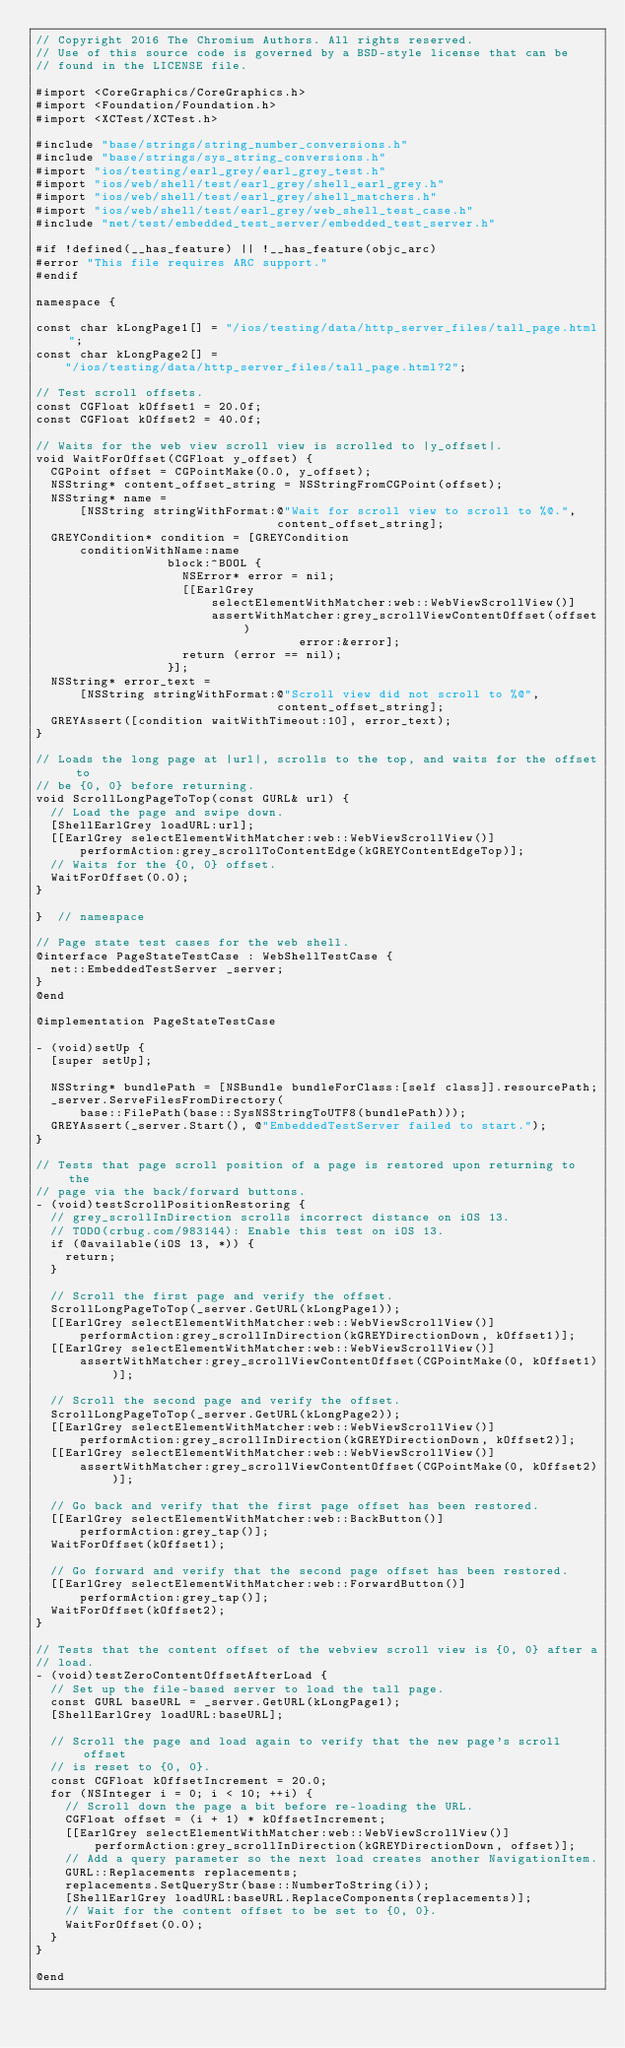<code> <loc_0><loc_0><loc_500><loc_500><_ObjectiveC_>// Copyright 2016 The Chromium Authors. All rights reserved.
// Use of this source code is governed by a BSD-style license that can be
// found in the LICENSE file.

#import <CoreGraphics/CoreGraphics.h>
#import <Foundation/Foundation.h>
#import <XCTest/XCTest.h>

#include "base/strings/string_number_conversions.h"
#include "base/strings/sys_string_conversions.h"
#import "ios/testing/earl_grey/earl_grey_test.h"
#import "ios/web/shell/test/earl_grey/shell_earl_grey.h"
#import "ios/web/shell/test/earl_grey/shell_matchers.h"
#import "ios/web/shell/test/earl_grey/web_shell_test_case.h"
#include "net/test/embedded_test_server/embedded_test_server.h"

#if !defined(__has_feature) || !__has_feature(objc_arc)
#error "This file requires ARC support."
#endif

namespace {

const char kLongPage1[] = "/ios/testing/data/http_server_files/tall_page.html";
const char kLongPage2[] =
    "/ios/testing/data/http_server_files/tall_page.html?2";

// Test scroll offsets.
const CGFloat kOffset1 = 20.0f;
const CGFloat kOffset2 = 40.0f;

// Waits for the web view scroll view is scrolled to |y_offset|.
void WaitForOffset(CGFloat y_offset) {
  CGPoint offset = CGPointMake(0.0, y_offset);
  NSString* content_offset_string = NSStringFromCGPoint(offset);
  NSString* name =
      [NSString stringWithFormat:@"Wait for scroll view to scroll to %@.",
                                 content_offset_string];
  GREYCondition* condition = [GREYCondition
      conditionWithName:name
                  block:^BOOL {
                    NSError* error = nil;
                    [[EarlGrey
                        selectElementWithMatcher:web::WebViewScrollView()]
                        assertWithMatcher:grey_scrollViewContentOffset(offset)
                                    error:&error];
                    return (error == nil);
                  }];
  NSString* error_text =
      [NSString stringWithFormat:@"Scroll view did not scroll to %@",
                                 content_offset_string];
  GREYAssert([condition waitWithTimeout:10], error_text);
}

// Loads the long page at |url|, scrolls to the top, and waits for the offset to
// be {0, 0} before returning.
void ScrollLongPageToTop(const GURL& url) {
  // Load the page and swipe down.
  [ShellEarlGrey loadURL:url];
  [[EarlGrey selectElementWithMatcher:web::WebViewScrollView()]
      performAction:grey_scrollToContentEdge(kGREYContentEdgeTop)];
  // Waits for the {0, 0} offset.
  WaitForOffset(0.0);
}

}  // namespace

// Page state test cases for the web shell.
@interface PageStateTestCase : WebShellTestCase {
  net::EmbeddedTestServer _server;
}
@end

@implementation PageStateTestCase

- (void)setUp {
  [super setUp];

  NSString* bundlePath = [NSBundle bundleForClass:[self class]].resourcePath;
  _server.ServeFilesFromDirectory(
      base::FilePath(base::SysNSStringToUTF8(bundlePath)));
  GREYAssert(_server.Start(), @"EmbeddedTestServer failed to start.");
}

// Tests that page scroll position of a page is restored upon returning to the
// page via the back/forward buttons.
- (void)testScrollPositionRestoring {
  // grey_scrollInDirection scrolls incorrect distance on iOS 13.
  // TODO(crbug.com/983144): Enable this test on iOS 13.
  if (@available(iOS 13, *)) {
    return;
  }

  // Scroll the first page and verify the offset.
  ScrollLongPageToTop(_server.GetURL(kLongPage1));
  [[EarlGrey selectElementWithMatcher:web::WebViewScrollView()]
      performAction:grey_scrollInDirection(kGREYDirectionDown, kOffset1)];
  [[EarlGrey selectElementWithMatcher:web::WebViewScrollView()]
      assertWithMatcher:grey_scrollViewContentOffset(CGPointMake(0, kOffset1))];

  // Scroll the second page and verify the offset.
  ScrollLongPageToTop(_server.GetURL(kLongPage2));
  [[EarlGrey selectElementWithMatcher:web::WebViewScrollView()]
      performAction:grey_scrollInDirection(kGREYDirectionDown, kOffset2)];
  [[EarlGrey selectElementWithMatcher:web::WebViewScrollView()]
      assertWithMatcher:grey_scrollViewContentOffset(CGPointMake(0, kOffset2))];

  // Go back and verify that the first page offset has been restored.
  [[EarlGrey selectElementWithMatcher:web::BackButton()]
      performAction:grey_tap()];
  WaitForOffset(kOffset1);

  // Go forward and verify that the second page offset has been restored.
  [[EarlGrey selectElementWithMatcher:web::ForwardButton()]
      performAction:grey_tap()];
  WaitForOffset(kOffset2);
}

// Tests that the content offset of the webview scroll view is {0, 0} after a
// load.
- (void)testZeroContentOffsetAfterLoad {
  // Set up the file-based server to load the tall page.
  const GURL baseURL = _server.GetURL(kLongPage1);
  [ShellEarlGrey loadURL:baseURL];

  // Scroll the page and load again to verify that the new page's scroll offset
  // is reset to {0, 0}.
  const CGFloat kOffsetIncrement = 20.0;
  for (NSInteger i = 0; i < 10; ++i) {
    // Scroll down the page a bit before re-loading the URL.
    CGFloat offset = (i + 1) * kOffsetIncrement;
    [[EarlGrey selectElementWithMatcher:web::WebViewScrollView()]
        performAction:grey_scrollInDirection(kGREYDirectionDown, offset)];
    // Add a query parameter so the next load creates another NavigationItem.
    GURL::Replacements replacements;
    replacements.SetQueryStr(base::NumberToString(i));
    [ShellEarlGrey loadURL:baseURL.ReplaceComponents(replacements)];
    // Wait for the content offset to be set to {0, 0}.
    WaitForOffset(0.0);
  }
}

@end
</code> 